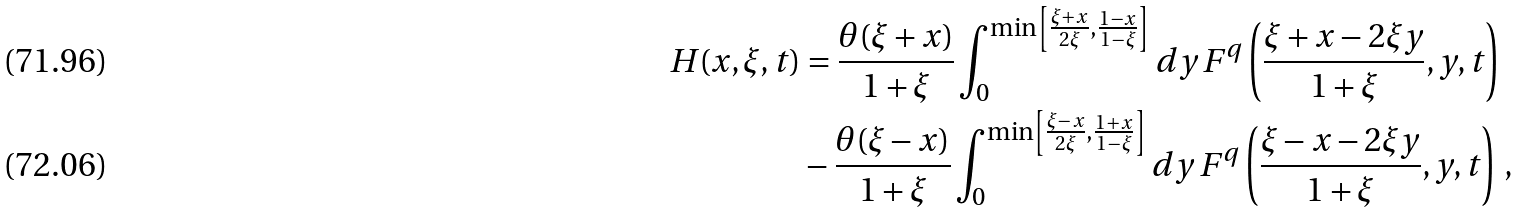<formula> <loc_0><loc_0><loc_500><loc_500>H ( x , \xi , t ) & = \frac { \theta ( \xi + x ) } { 1 + \xi } \int _ { 0 } ^ { \min \left [ \frac { \xi + x } { 2 \xi } , \frac { 1 - x } { 1 - \xi } \right ] } d y \, F ^ { q } \left ( \frac { \xi + x - 2 \xi y } { 1 + \xi } , y , t \right ) \\ & - \frac { \theta ( \xi - x ) } { 1 + \xi } \int _ { 0 } ^ { \min \left [ \frac { \xi - x } { 2 \xi } , \frac { 1 + x } { 1 - \xi } \right ] } d y \, F ^ { q } \left ( \frac { \xi - x - 2 \xi y } { 1 + \xi } , y , t \right ) \, ,</formula> 